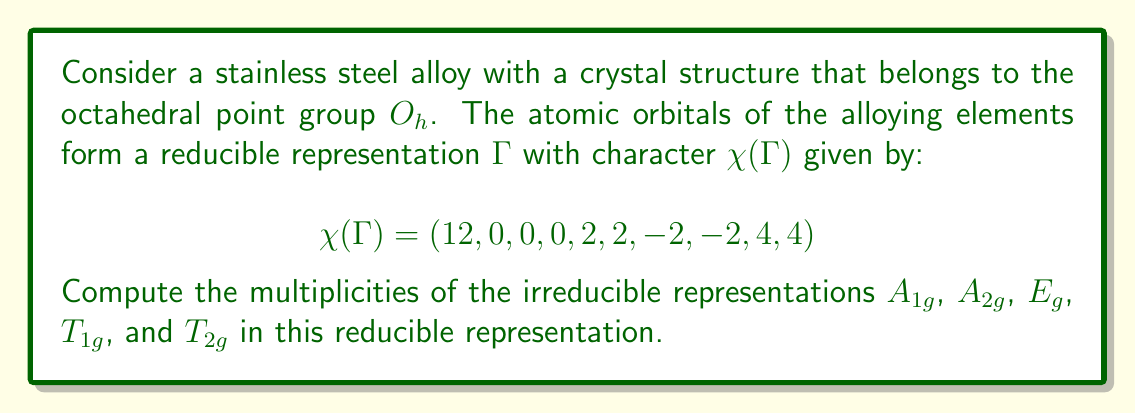Show me your answer to this math problem. To find the multiplicities of irreducible representations in a reducible representation, we use the formula:

$$a_i = \frac{1}{h} \sum_{R} \chi_i(R) \chi(R) n_R$$

Where:
$a_i$ is the multiplicity of the irreducible representation $i$
$h$ is the order of the group (48 for $O_h$)
$R$ are the symmetry operations
$\chi_i(R)$ is the character of the irreducible representation for operation $R$
$\chi(R)$ is the character of the reducible representation for operation $R$
$n_R$ is the number of elements in the class of $R$

Step 1: Obtain the character table for $O_h$ group.

Step 2: Calculate $a_i$ for each irreducible representation:

For $A_{1g}$:
$$a_{A_{1g}} = \frac{1}{48}(1 \cdot 12 \cdot 1 + 1 \cdot 0 \cdot 8 + 1 \cdot 0 \cdot 3 + 1 \cdot 0 \cdot 6 + 1 \cdot 2 \cdot 6 + 1 \cdot 2 \cdot 8 + 1 \cdot (-2) \cdot 6 + 1 \cdot (-2) \cdot 8 + 1 \cdot 4 \cdot 1 + 1 \cdot 4 \cdot 1) = 1$$

For $A_{2g}$:
$$a_{A_{2g}} = \frac{1}{48}(1 \cdot 12 \cdot 1 + 1 \cdot 0 \cdot 8 + 1 \cdot 0 \cdot 3 + 1 \cdot 0 \cdot 6 + (-1) \cdot 2 \cdot 6 + (-1) \cdot 2 \cdot 8 + (-1) \cdot (-2) \cdot 6 + (-1) \cdot (-2) \cdot 8 + 1 \cdot 4 \cdot 1 + 1 \cdot 4 \cdot 1) = 0$$

For $E_g$:
$$a_{E_g} = \frac{1}{48}(2 \cdot 12 \cdot 1 + 2 \cdot 0 \cdot 8 + (-1) \cdot 0 \cdot 3 + 0 \cdot 0 \cdot 6 + 0 \cdot 2 \cdot 6 + 0 \cdot 2 \cdot 8 + 0 \cdot (-2) \cdot 6 + 0 \cdot (-2) \cdot 8 + (-1) \cdot 4 \cdot 1 + 2 \cdot 4 \cdot 1) = 1$$

For $T_{1g}$:
$$a_{T_{1g}} = \frac{1}{48}(3 \cdot 12 \cdot 1 + (-1) \cdot 0 \cdot 8 + 0 \cdot 0 \cdot 3 + 1 \cdot 0 \cdot 6 + (-1) \cdot 2 \cdot 6 + 1 \cdot 2 \cdot 8 + 1 \cdot (-2) \cdot 6 + (-1) \cdot (-2) \cdot 8 + 0 \cdot 4 \cdot 1 + (-1) \cdot 4 \cdot 1) = 0$$

For $T_{2g}$:
$$a_{T_{2g}} = \frac{1}{48}(3 \cdot 12 \cdot 1 + (-1) \cdot 0 \cdot 8 + 0 \cdot 0 \cdot 3 + 1 \cdot 0 \cdot 6 + 1 \cdot 2 \cdot 6 + (-1) \cdot 2 \cdot 8 + (-1) \cdot (-2) \cdot 6 + 1 \cdot (-2) \cdot 8 + 0 \cdot 4 \cdot 1 + (-1) \cdot 4 \cdot 1) = 1$$

Step 3: Collect the results.
Answer: $A_{1g}: 1$, $A_{2g}: 0$, $E_g: 1$, $T_{1g}: 0$, $T_{2g}: 1$ 